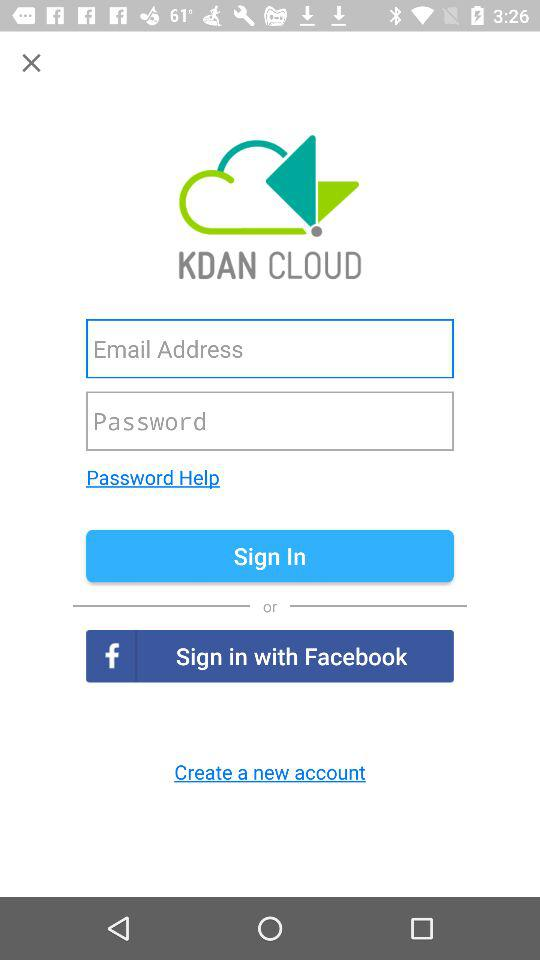What is the name of the application? The name of the application is "KDAN CLOUD". 